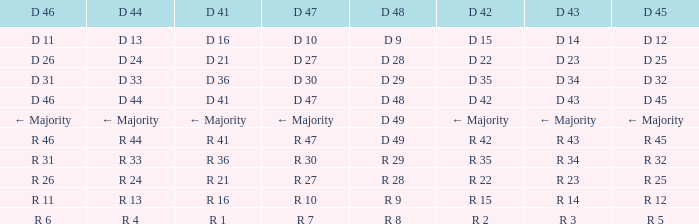Name the D 47 when it has a D 48 of d 49 and D 42 of r 42 R 47. 